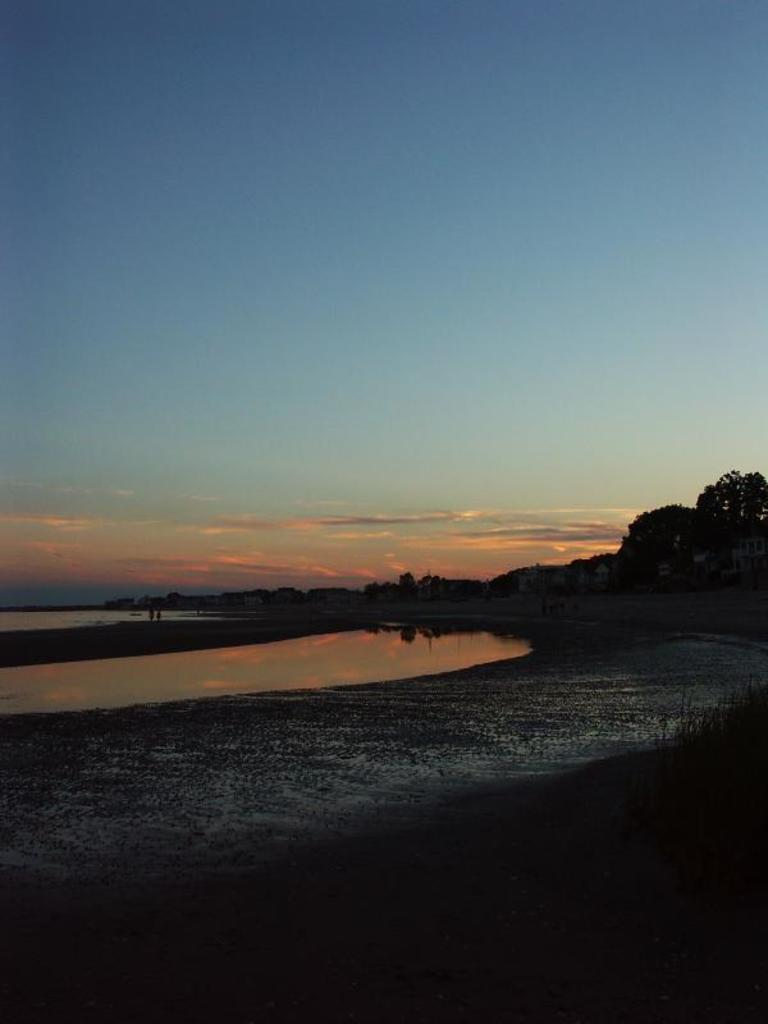What type of terrain is visible in the image? There is ground visible in the image. What natural element is also present in the image? There is water visible in the image. Are there any man-made structures in the image? Yes, there are buildings in the image. What type of vegetation can be seen in the image? There are trees in the image. What is visible in the background of the image? The sky is visible in the background of the image. What type of jam is being spread on the buildings in the image? There is no jam present in the image; it features ground, water, buildings, trees, and the sky. 